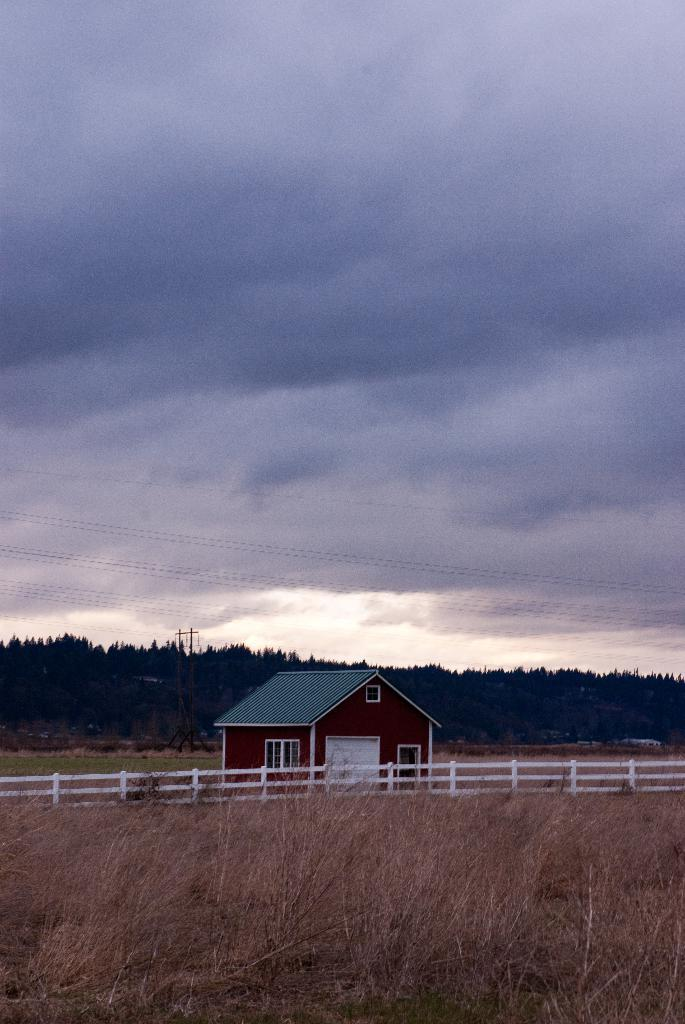What is the main structure in the image? There is a hut at the center of the image. What is in front of the hut? There is a railing in front of the hut. What type of vegetation is present in front of the hut? There is dry grass in front of the hut. What can be seen in the background of the image? There are trees and the sky visible in the background of the image. How many rabbits can be seen playing in the grass in the image? There are no rabbits present in the image; it features a hut, a railing, dry grass, trees, and the sky. What type of weather is indicated by the presence of thunder in the image? There is no thunder present in the image; it features a hut, a railing, dry grass, trees, and the sky. 